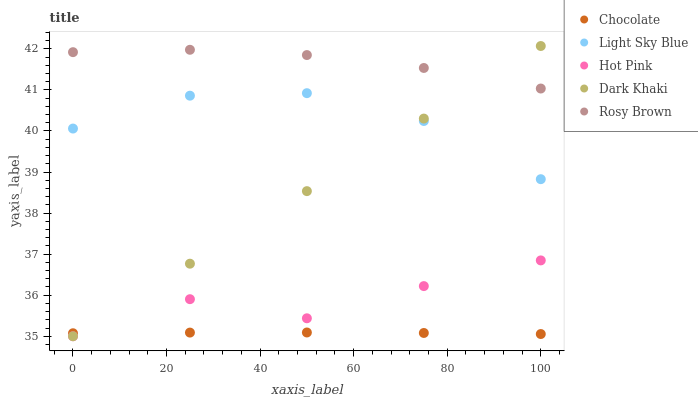Does Chocolate have the minimum area under the curve?
Answer yes or no. Yes. Does Rosy Brown have the maximum area under the curve?
Answer yes or no. Yes. Does Hot Pink have the minimum area under the curve?
Answer yes or no. No. Does Hot Pink have the maximum area under the curve?
Answer yes or no. No. Is Dark Khaki the smoothest?
Answer yes or no. Yes. Is Hot Pink the roughest?
Answer yes or no. Yes. Is Light Sky Blue the smoothest?
Answer yes or no. No. Is Light Sky Blue the roughest?
Answer yes or no. No. Does Dark Khaki have the lowest value?
Answer yes or no. Yes. Does Light Sky Blue have the lowest value?
Answer yes or no. No. Does Dark Khaki have the highest value?
Answer yes or no. Yes. Does Hot Pink have the highest value?
Answer yes or no. No. Is Hot Pink less than Rosy Brown?
Answer yes or no. Yes. Is Rosy Brown greater than Hot Pink?
Answer yes or no. Yes. Does Light Sky Blue intersect Dark Khaki?
Answer yes or no. Yes. Is Light Sky Blue less than Dark Khaki?
Answer yes or no. No. Is Light Sky Blue greater than Dark Khaki?
Answer yes or no. No. Does Hot Pink intersect Rosy Brown?
Answer yes or no. No. 